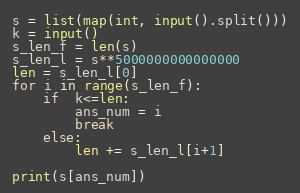<code> <loc_0><loc_0><loc_500><loc_500><_Python_>s = list(map(int, input().split()))
k = input()
s_len_f = len(s)
s_len_l = s**5000000000000000
len = s_len_l[0]
for i in range(s_len_f):
    if  k<=len:
        ans_num = i
        break
    else:
        len += s_len_l[i+1]

print(s[ans_num])</code> 